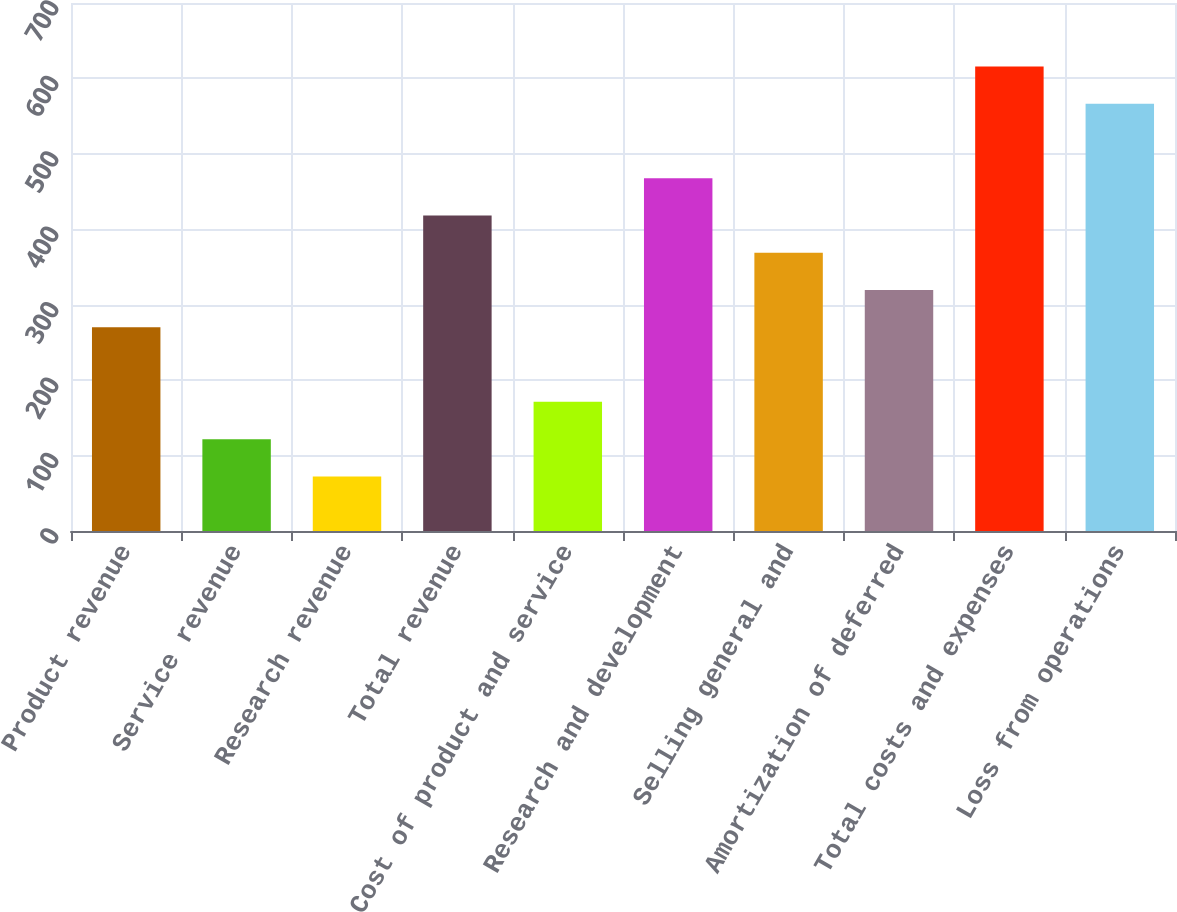Convert chart. <chart><loc_0><loc_0><loc_500><loc_500><bar_chart><fcel>Product revenue<fcel>Service revenue<fcel>Research revenue<fcel>Total revenue<fcel>Cost of product and service<fcel>Research and development<fcel>Selling general and<fcel>Amortization of deferred<fcel>Total costs and expenses<fcel>Loss from operations<nl><fcel>270<fcel>121.8<fcel>72.4<fcel>418.2<fcel>171.2<fcel>467.6<fcel>368.8<fcel>319.4<fcel>615.8<fcel>566.4<nl></chart> 